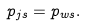<formula> <loc_0><loc_0><loc_500><loc_500>p _ { j s } = p _ { w s } .</formula> 